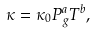Convert formula to latex. <formula><loc_0><loc_0><loc_500><loc_500>\kappa = \kappa _ { 0 } P _ { g } ^ { a } T ^ { b } ,</formula> 